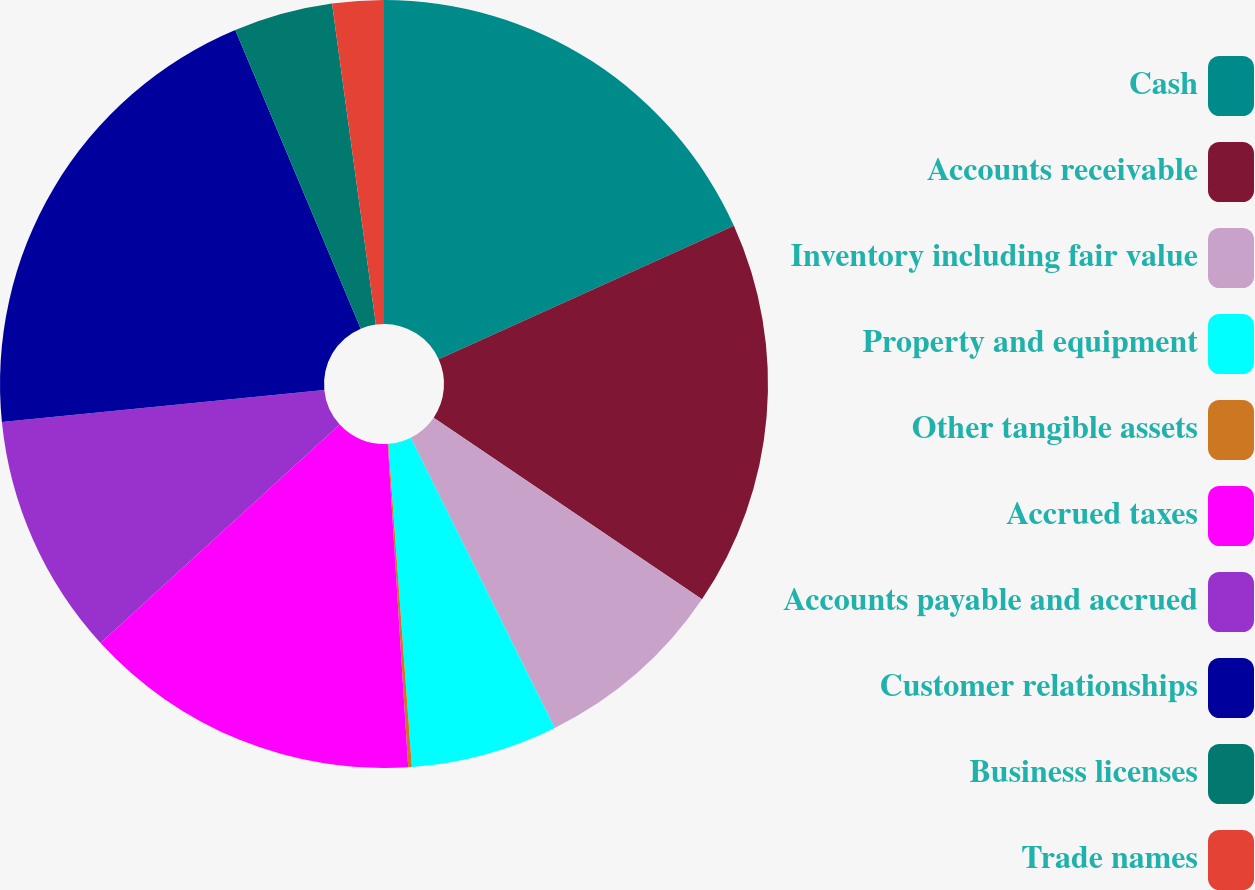Convert chart to OTSL. <chart><loc_0><loc_0><loc_500><loc_500><pie_chart><fcel>Cash<fcel>Accounts receivable<fcel>Inventory including fair value<fcel>Property and equipment<fcel>Other tangible assets<fcel>Accrued taxes<fcel>Accounts payable and accrued<fcel>Customer relationships<fcel>Business licenses<fcel>Trade names<nl><fcel>18.24%<fcel>16.23%<fcel>8.19%<fcel>6.18%<fcel>0.15%<fcel>14.22%<fcel>10.2%<fcel>20.25%<fcel>4.17%<fcel>2.16%<nl></chart> 